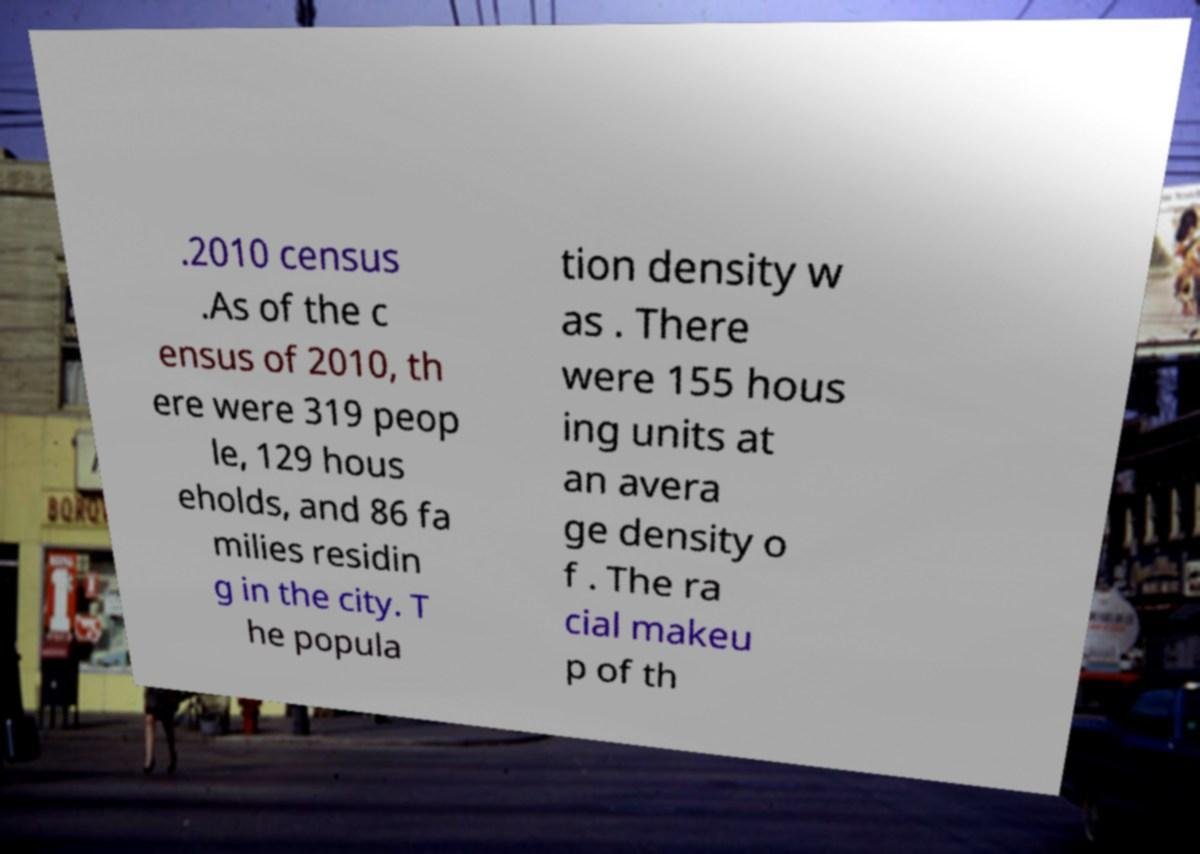For documentation purposes, I need the text within this image transcribed. Could you provide that? .2010 census .As of the c ensus of 2010, th ere were 319 peop le, 129 hous eholds, and 86 fa milies residin g in the city. T he popula tion density w as . There were 155 hous ing units at an avera ge density o f . The ra cial makeu p of th 